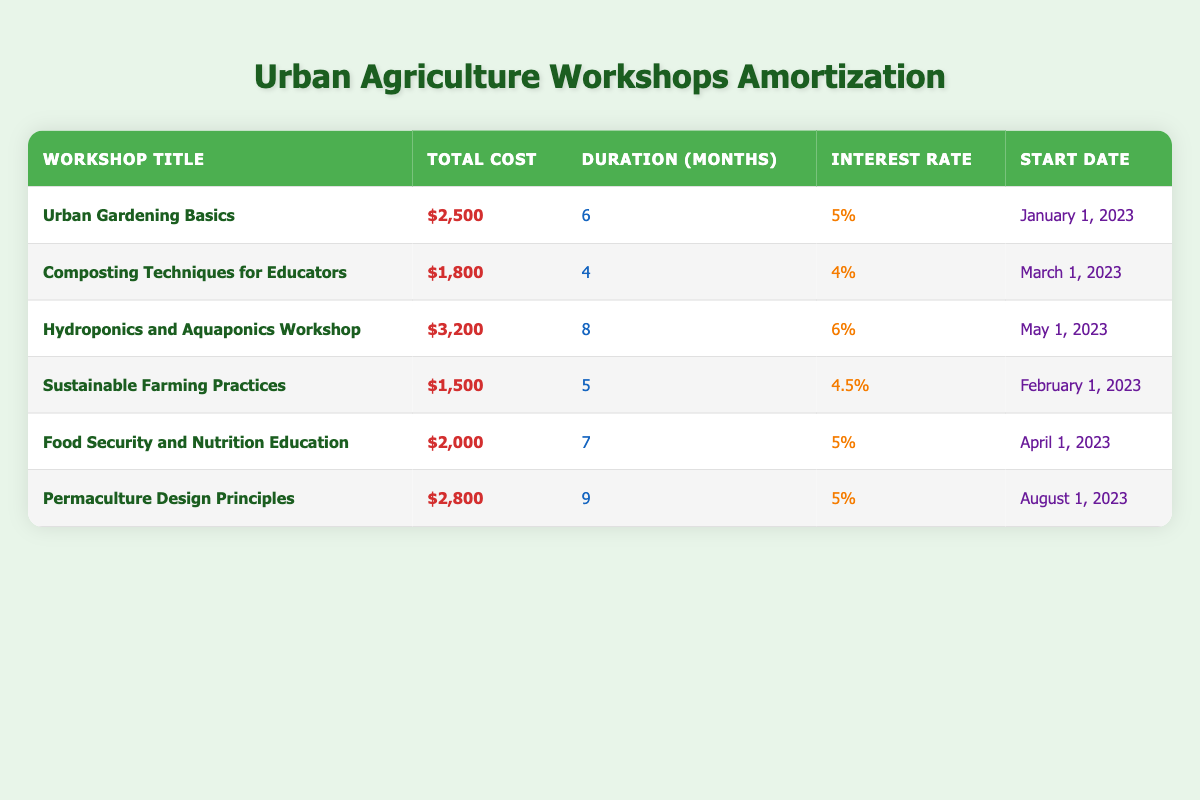What is the total cost of the "Hydroponics and Aquaponics Workshop"? Looking at the table, we find the row corresponding to "Hydroponics and Aquaponics Workshop", and the value in the "Total Cost" column is $3,200.
Answer: $3,200 How many months does the "Composting Techniques for Educators" workshop last? In the table, find the row for "Composting Techniques for Educators" and observe the "Duration" column, which indicates it lasts for 4 months.
Answer: 4 Is the interest rate for the "Food Security and Nutrition Education" workshop 5%? We can check the "Interest Rate" column in the row for "Food Security and Nutrition Education" and confirm that it indeed says 5%.
Answer: Yes What is the average duration of all the workshops? To find the average, we first sum the durations: 6 + 4 + 8 + 5 + 7 + 9 = 39 months. There are 6 workshops, so the average duration is 39/6 = 6.5 months.
Answer: 6.5 Which workshop has the highest total cost? To identify this, we compare the "Total Cost" values: $2,500 (Urban Gardening Basics), $1,800 (Composting Techniques for Educators), $3,200 (Hydroponics and Aquaponics Workshop), $1,500 (Sustainable Farming Practices), $2,000 (Food Security and Nutrition Education), and $2,800 (Permaculture Design Principles). The highest value is $3,200 for Hydroponics and Aquaponics Workshop.
Answer: Hydroponics and Aquaponics Workshop Are all workshops starting in the first half of 2023? We need to examine the "Start Date" column for each workshop. The dates show that some workshops do start in the first half (Urban Gardening Basics, Composting Techniques for Educators, Sustainable Farming Practices, and Food Security and Nutrition Education), while "Hydroponics and Aquaponics Workshop" starts in May 2023 and "Permaculture Design Principles" in August 2023, hence not all start in the first half.
Answer: No What is the total cost of workshops that last longer than 6 months? Identifying workshops longer than 6 months, we find "Hydroponics and Aquaponics Workshop" (8 months) and "Permaculture Design Principles" (9 months). Their costs are $3,200 and $2,800 respectively. Therefore, the total cost is 3,200 + 2,800 = $6,000.
Answer: $6,000 Which workshop started the earliest and what is its total cost? By looking at the "Start Date" column, "Urban Gardening Basics" starts on January 1, 2023, which is the earliest date, and it has a total cost of $2,500.
Answer: Urban Gardening Basics; $2,500 How many workshops have an interest rate higher than 5%? We scan through the "Interest Rate" column. The workshops with rates greater than 5% are "Hydroponics and Aquaponics Workshop" (6%) and "Composting Techniques for Educators" (4%). Thus, only one workshop has an interest rate greater than 5%.
Answer: 1 